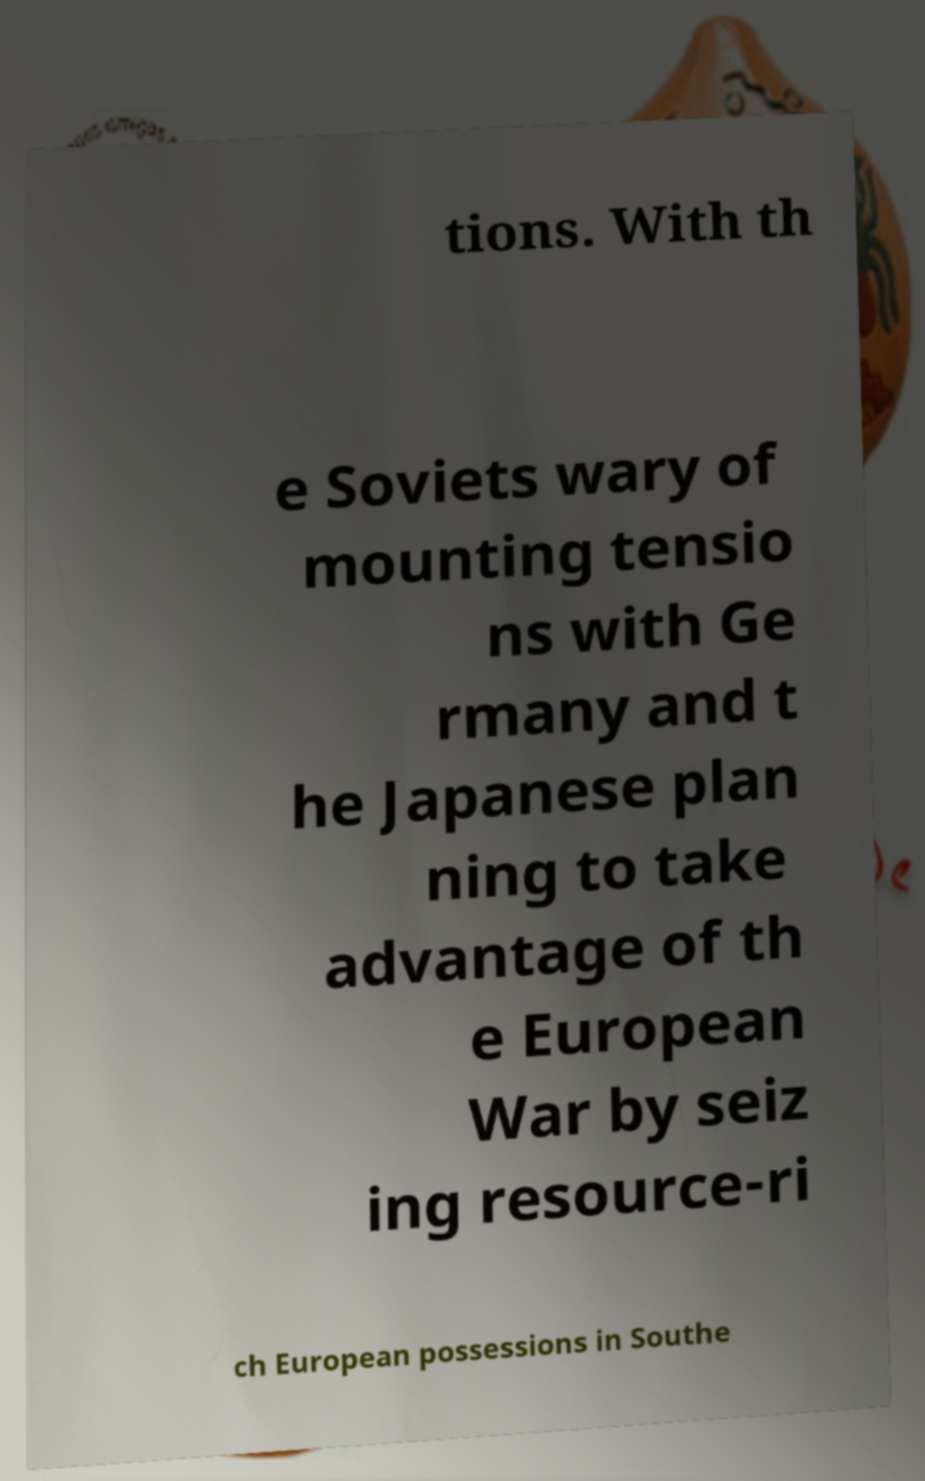Please read and relay the text visible in this image. What does it say? tions. With th e Soviets wary of mounting tensio ns with Ge rmany and t he Japanese plan ning to take advantage of th e European War by seiz ing resource-ri ch European possessions in Southe 